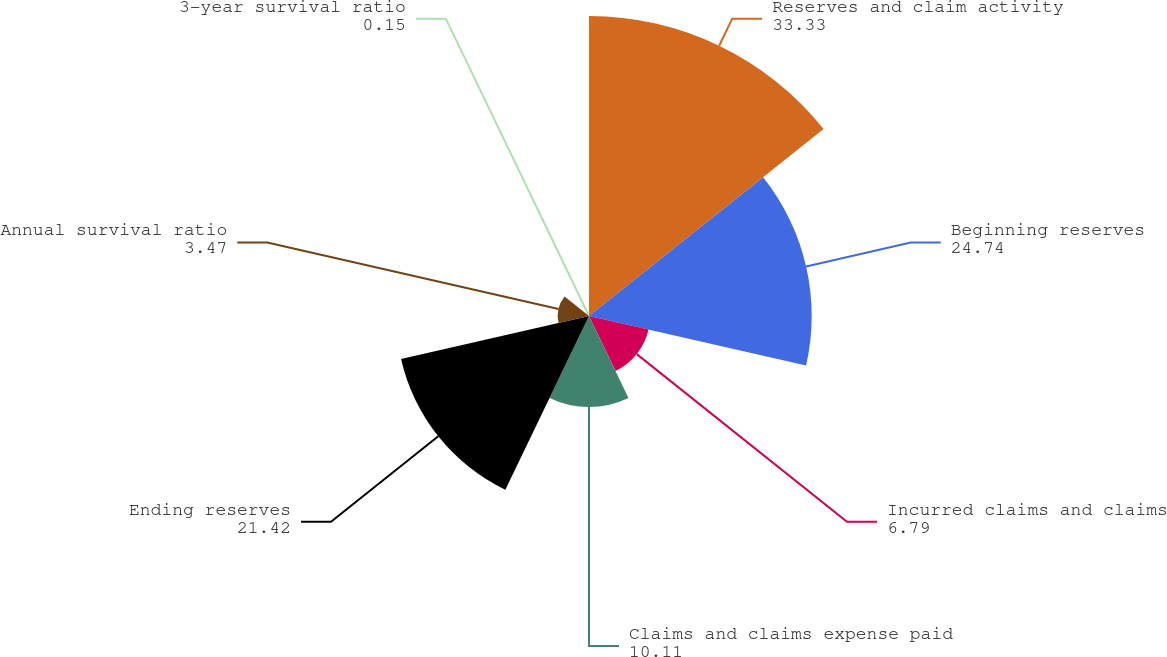Convert chart. <chart><loc_0><loc_0><loc_500><loc_500><pie_chart><fcel>Reserves and claim activity<fcel>Beginning reserves<fcel>Incurred claims and claims<fcel>Claims and claims expense paid<fcel>Ending reserves<fcel>Annual survival ratio<fcel>3-year survival ratio<nl><fcel>33.33%<fcel>24.74%<fcel>6.79%<fcel>10.11%<fcel>21.42%<fcel>3.47%<fcel>0.15%<nl></chart> 